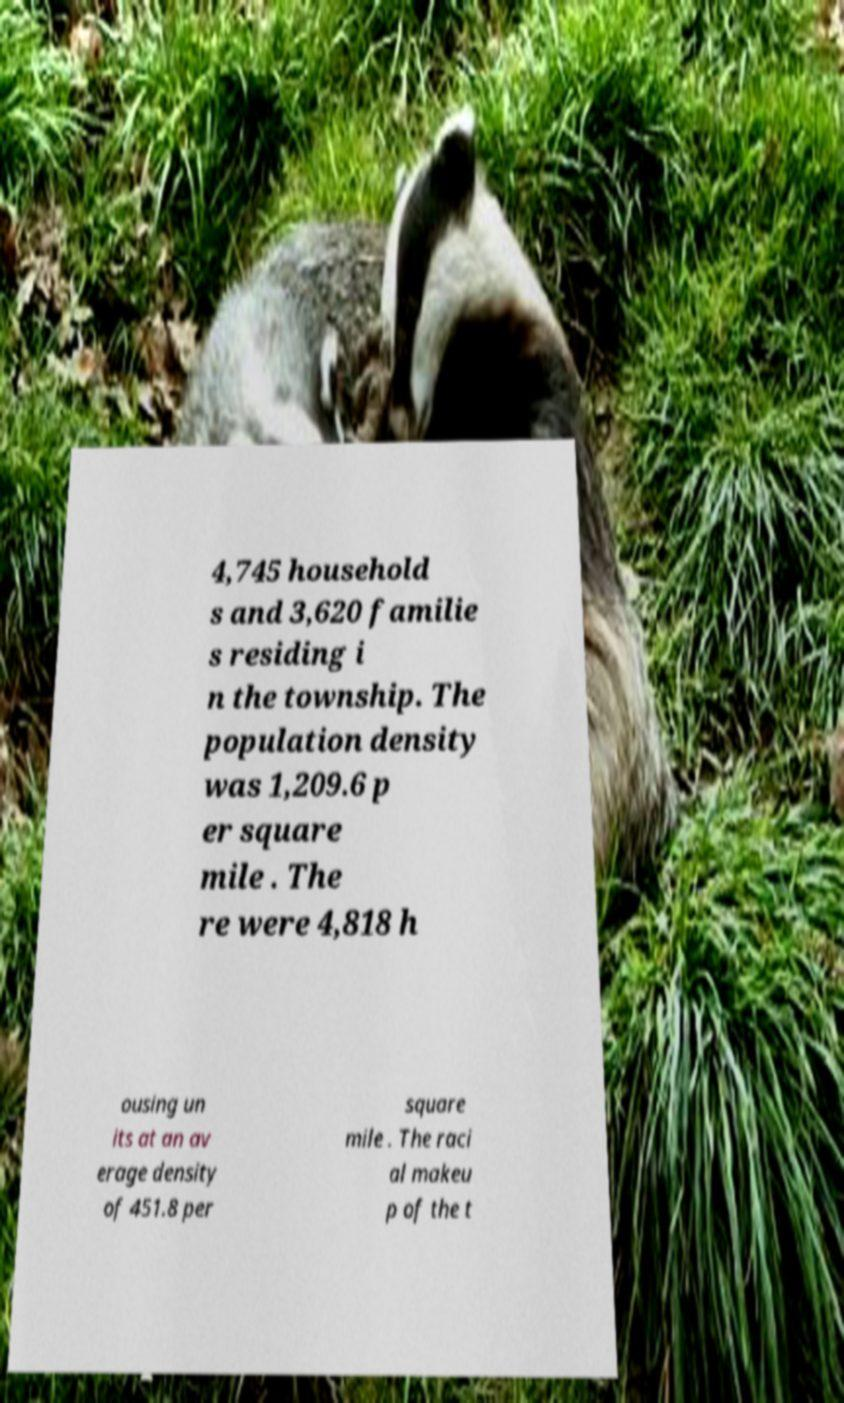Can you accurately transcribe the text from the provided image for me? 4,745 household s and 3,620 familie s residing i n the township. The population density was 1,209.6 p er square mile . The re were 4,818 h ousing un its at an av erage density of 451.8 per square mile . The raci al makeu p of the t 